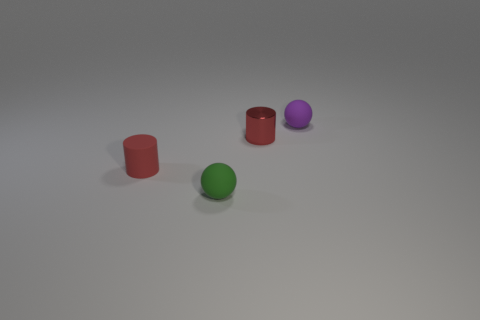There is a object to the left of the green object; what shape is it?
Make the answer very short. Cylinder. Do the small sphere that is left of the purple matte ball and the small metallic cylinder have the same color?
Keep it short and to the point. No. Are there fewer tiny metallic things in front of the green rubber object than matte spheres?
Your answer should be compact. Yes. There is another small ball that is the same material as the tiny purple ball; what is its color?
Provide a succinct answer. Green. There is a rubber ball in front of the purple matte sphere; what size is it?
Make the answer very short. Small. Is the small purple ball made of the same material as the small green ball?
Ensure brevity in your answer.  Yes. There is a red object behind the small red thing in front of the tiny metallic cylinder; is there a green rubber thing right of it?
Provide a succinct answer. No. The metal cylinder has what color?
Your answer should be very brief. Red. What is the color of the shiny cylinder that is the same size as the red matte cylinder?
Make the answer very short. Red. There is a rubber object that is on the right side of the tiny red metal object; does it have the same shape as the green matte object?
Your response must be concise. Yes. 